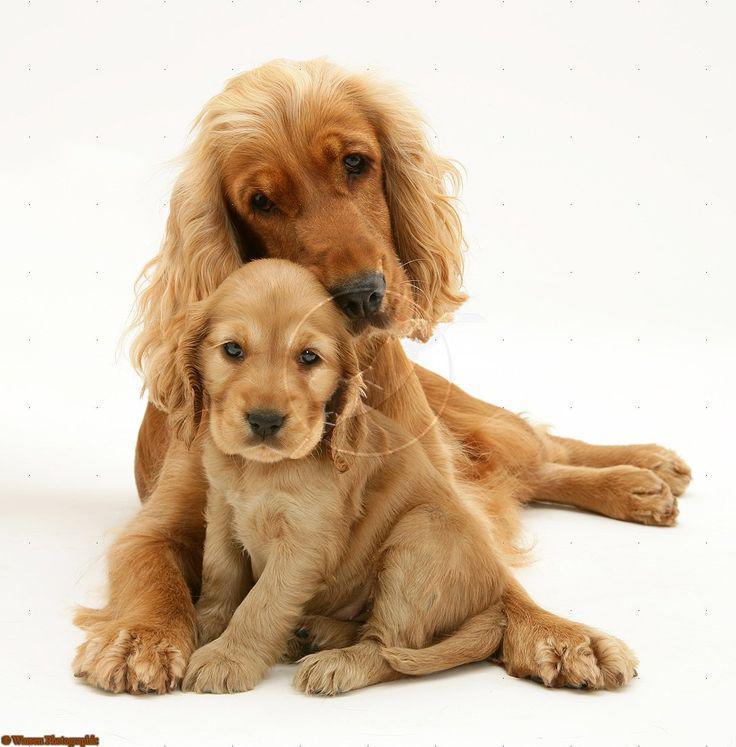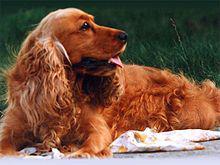The first image is the image on the left, the second image is the image on the right. Given the left and right images, does the statement "Exactly two dogs are shown with background settings, each of them the same tan coloring with dark eyes, one wearing a collar and the other not" hold true? Answer yes or no. No. The first image is the image on the left, the second image is the image on the right. Given the left and right images, does the statement "An image shows a reddish spaniel dog with its paws over a blanket-like piece of fabric." hold true? Answer yes or no. Yes. 